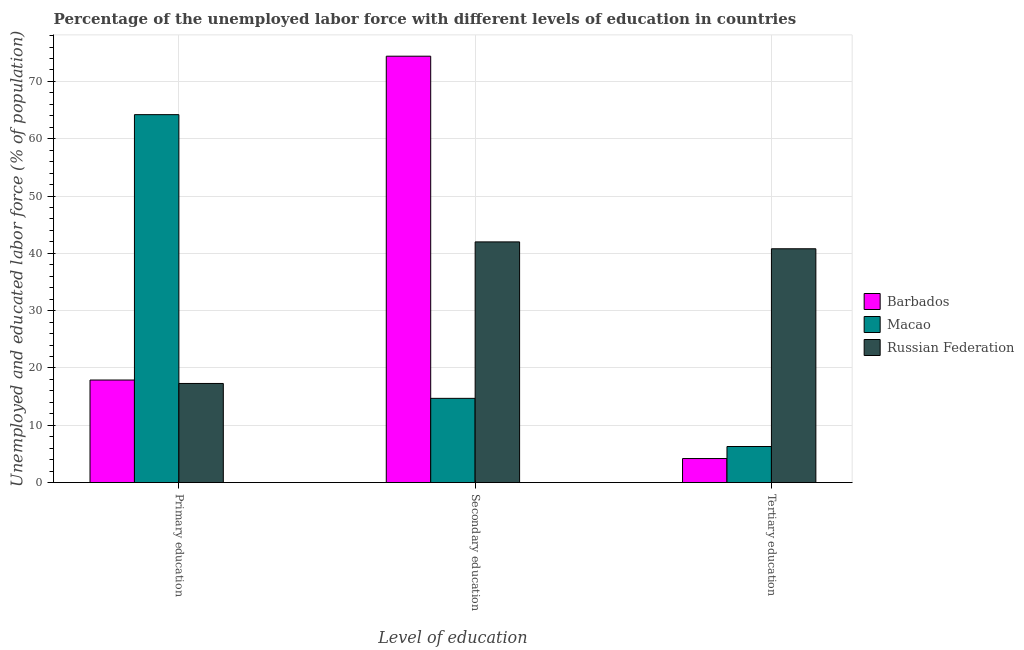How many groups of bars are there?
Give a very brief answer. 3. What is the label of the 3rd group of bars from the left?
Give a very brief answer. Tertiary education. What is the percentage of labor force who received secondary education in Barbados?
Offer a very short reply. 74.4. Across all countries, what is the maximum percentage of labor force who received primary education?
Provide a short and direct response. 64.2. Across all countries, what is the minimum percentage of labor force who received tertiary education?
Give a very brief answer. 4.2. In which country was the percentage of labor force who received secondary education maximum?
Give a very brief answer. Barbados. In which country was the percentage of labor force who received primary education minimum?
Your answer should be very brief. Russian Federation. What is the total percentage of labor force who received tertiary education in the graph?
Provide a short and direct response. 51.3. What is the difference between the percentage of labor force who received tertiary education in Russian Federation and that in Barbados?
Your answer should be compact. 36.6. What is the difference between the percentage of labor force who received tertiary education in Macao and the percentage of labor force who received primary education in Barbados?
Provide a succinct answer. -11.6. What is the average percentage of labor force who received secondary education per country?
Your response must be concise. 43.7. What is the difference between the percentage of labor force who received primary education and percentage of labor force who received tertiary education in Macao?
Ensure brevity in your answer.  57.9. What is the ratio of the percentage of labor force who received secondary education in Macao to that in Barbados?
Make the answer very short. 0.2. Is the difference between the percentage of labor force who received primary education in Russian Federation and Barbados greater than the difference between the percentage of labor force who received tertiary education in Russian Federation and Barbados?
Offer a very short reply. No. What is the difference between the highest and the second highest percentage of labor force who received tertiary education?
Make the answer very short. 34.5. What is the difference between the highest and the lowest percentage of labor force who received secondary education?
Provide a succinct answer. 59.7. Is the sum of the percentage of labor force who received secondary education in Barbados and Russian Federation greater than the maximum percentage of labor force who received tertiary education across all countries?
Give a very brief answer. Yes. What does the 3rd bar from the left in Tertiary education represents?
Give a very brief answer. Russian Federation. What does the 3rd bar from the right in Tertiary education represents?
Keep it short and to the point. Barbados. Is it the case that in every country, the sum of the percentage of labor force who received primary education and percentage of labor force who received secondary education is greater than the percentage of labor force who received tertiary education?
Keep it short and to the point. Yes. How many bars are there?
Make the answer very short. 9. Are all the bars in the graph horizontal?
Provide a succinct answer. No. How many countries are there in the graph?
Keep it short and to the point. 3. What is the difference between two consecutive major ticks on the Y-axis?
Provide a short and direct response. 10. Does the graph contain any zero values?
Offer a very short reply. No. How many legend labels are there?
Provide a short and direct response. 3. What is the title of the graph?
Make the answer very short. Percentage of the unemployed labor force with different levels of education in countries. What is the label or title of the X-axis?
Provide a succinct answer. Level of education. What is the label or title of the Y-axis?
Your answer should be compact. Unemployed and educated labor force (% of population). What is the Unemployed and educated labor force (% of population) of Barbados in Primary education?
Your answer should be compact. 17.9. What is the Unemployed and educated labor force (% of population) of Macao in Primary education?
Make the answer very short. 64.2. What is the Unemployed and educated labor force (% of population) in Russian Federation in Primary education?
Give a very brief answer. 17.3. What is the Unemployed and educated labor force (% of population) in Barbados in Secondary education?
Give a very brief answer. 74.4. What is the Unemployed and educated labor force (% of population) in Macao in Secondary education?
Your answer should be compact. 14.7. What is the Unemployed and educated labor force (% of population) of Barbados in Tertiary education?
Your answer should be compact. 4.2. What is the Unemployed and educated labor force (% of population) of Macao in Tertiary education?
Offer a terse response. 6.3. What is the Unemployed and educated labor force (% of population) in Russian Federation in Tertiary education?
Your answer should be compact. 40.8. Across all Level of education, what is the maximum Unemployed and educated labor force (% of population) of Barbados?
Make the answer very short. 74.4. Across all Level of education, what is the maximum Unemployed and educated labor force (% of population) in Macao?
Your answer should be compact. 64.2. Across all Level of education, what is the maximum Unemployed and educated labor force (% of population) of Russian Federation?
Give a very brief answer. 42. Across all Level of education, what is the minimum Unemployed and educated labor force (% of population) in Barbados?
Your answer should be very brief. 4.2. Across all Level of education, what is the minimum Unemployed and educated labor force (% of population) in Macao?
Provide a succinct answer. 6.3. Across all Level of education, what is the minimum Unemployed and educated labor force (% of population) of Russian Federation?
Your answer should be very brief. 17.3. What is the total Unemployed and educated labor force (% of population) of Barbados in the graph?
Keep it short and to the point. 96.5. What is the total Unemployed and educated labor force (% of population) of Macao in the graph?
Your answer should be very brief. 85.2. What is the total Unemployed and educated labor force (% of population) of Russian Federation in the graph?
Your answer should be compact. 100.1. What is the difference between the Unemployed and educated labor force (% of population) in Barbados in Primary education and that in Secondary education?
Provide a short and direct response. -56.5. What is the difference between the Unemployed and educated labor force (% of population) of Macao in Primary education and that in Secondary education?
Ensure brevity in your answer.  49.5. What is the difference between the Unemployed and educated labor force (% of population) of Russian Federation in Primary education and that in Secondary education?
Provide a short and direct response. -24.7. What is the difference between the Unemployed and educated labor force (% of population) of Macao in Primary education and that in Tertiary education?
Give a very brief answer. 57.9. What is the difference between the Unemployed and educated labor force (% of population) of Russian Federation in Primary education and that in Tertiary education?
Ensure brevity in your answer.  -23.5. What is the difference between the Unemployed and educated labor force (% of population) of Barbados in Secondary education and that in Tertiary education?
Make the answer very short. 70.2. What is the difference between the Unemployed and educated labor force (% of population) in Barbados in Primary education and the Unemployed and educated labor force (% of population) in Macao in Secondary education?
Offer a terse response. 3.2. What is the difference between the Unemployed and educated labor force (% of population) of Barbados in Primary education and the Unemployed and educated labor force (% of population) of Russian Federation in Secondary education?
Provide a succinct answer. -24.1. What is the difference between the Unemployed and educated labor force (% of population) of Macao in Primary education and the Unemployed and educated labor force (% of population) of Russian Federation in Secondary education?
Make the answer very short. 22.2. What is the difference between the Unemployed and educated labor force (% of population) in Barbados in Primary education and the Unemployed and educated labor force (% of population) in Macao in Tertiary education?
Provide a short and direct response. 11.6. What is the difference between the Unemployed and educated labor force (% of population) of Barbados in Primary education and the Unemployed and educated labor force (% of population) of Russian Federation in Tertiary education?
Provide a succinct answer. -22.9. What is the difference between the Unemployed and educated labor force (% of population) in Macao in Primary education and the Unemployed and educated labor force (% of population) in Russian Federation in Tertiary education?
Offer a terse response. 23.4. What is the difference between the Unemployed and educated labor force (% of population) of Barbados in Secondary education and the Unemployed and educated labor force (% of population) of Macao in Tertiary education?
Your answer should be very brief. 68.1. What is the difference between the Unemployed and educated labor force (% of population) in Barbados in Secondary education and the Unemployed and educated labor force (% of population) in Russian Federation in Tertiary education?
Your answer should be compact. 33.6. What is the difference between the Unemployed and educated labor force (% of population) in Macao in Secondary education and the Unemployed and educated labor force (% of population) in Russian Federation in Tertiary education?
Offer a very short reply. -26.1. What is the average Unemployed and educated labor force (% of population) of Barbados per Level of education?
Make the answer very short. 32.17. What is the average Unemployed and educated labor force (% of population) of Macao per Level of education?
Provide a succinct answer. 28.4. What is the average Unemployed and educated labor force (% of population) in Russian Federation per Level of education?
Provide a short and direct response. 33.37. What is the difference between the Unemployed and educated labor force (% of population) in Barbados and Unemployed and educated labor force (% of population) in Macao in Primary education?
Provide a short and direct response. -46.3. What is the difference between the Unemployed and educated labor force (% of population) of Macao and Unemployed and educated labor force (% of population) of Russian Federation in Primary education?
Your response must be concise. 46.9. What is the difference between the Unemployed and educated labor force (% of population) in Barbados and Unemployed and educated labor force (% of population) in Macao in Secondary education?
Give a very brief answer. 59.7. What is the difference between the Unemployed and educated labor force (% of population) of Barbados and Unemployed and educated labor force (% of population) of Russian Federation in Secondary education?
Provide a succinct answer. 32.4. What is the difference between the Unemployed and educated labor force (% of population) in Macao and Unemployed and educated labor force (% of population) in Russian Federation in Secondary education?
Give a very brief answer. -27.3. What is the difference between the Unemployed and educated labor force (% of population) in Barbados and Unemployed and educated labor force (% of population) in Macao in Tertiary education?
Offer a very short reply. -2.1. What is the difference between the Unemployed and educated labor force (% of population) in Barbados and Unemployed and educated labor force (% of population) in Russian Federation in Tertiary education?
Offer a terse response. -36.6. What is the difference between the Unemployed and educated labor force (% of population) of Macao and Unemployed and educated labor force (% of population) of Russian Federation in Tertiary education?
Provide a short and direct response. -34.5. What is the ratio of the Unemployed and educated labor force (% of population) of Barbados in Primary education to that in Secondary education?
Ensure brevity in your answer.  0.24. What is the ratio of the Unemployed and educated labor force (% of population) in Macao in Primary education to that in Secondary education?
Keep it short and to the point. 4.37. What is the ratio of the Unemployed and educated labor force (% of population) of Russian Federation in Primary education to that in Secondary education?
Offer a very short reply. 0.41. What is the ratio of the Unemployed and educated labor force (% of population) of Barbados in Primary education to that in Tertiary education?
Offer a terse response. 4.26. What is the ratio of the Unemployed and educated labor force (% of population) of Macao in Primary education to that in Tertiary education?
Offer a terse response. 10.19. What is the ratio of the Unemployed and educated labor force (% of population) of Russian Federation in Primary education to that in Tertiary education?
Offer a terse response. 0.42. What is the ratio of the Unemployed and educated labor force (% of population) of Barbados in Secondary education to that in Tertiary education?
Your response must be concise. 17.71. What is the ratio of the Unemployed and educated labor force (% of population) of Macao in Secondary education to that in Tertiary education?
Your response must be concise. 2.33. What is the ratio of the Unemployed and educated labor force (% of population) in Russian Federation in Secondary education to that in Tertiary education?
Keep it short and to the point. 1.03. What is the difference between the highest and the second highest Unemployed and educated labor force (% of population) in Barbados?
Your answer should be compact. 56.5. What is the difference between the highest and the second highest Unemployed and educated labor force (% of population) in Macao?
Offer a very short reply. 49.5. What is the difference between the highest and the second highest Unemployed and educated labor force (% of population) in Russian Federation?
Provide a short and direct response. 1.2. What is the difference between the highest and the lowest Unemployed and educated labor force (% of population) in Barbados?
Provide a short and direct response. 70.2. What is the difference between the highest and the lowest Unemployed and educated labor force (% of population) of Macao?
Give a very brief answer. 57.9. What is the difference between the highest and the lowest Unemployed and educated labor force (% of population) of Russian Federation?
Offer a terse response. 24.7. 